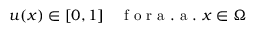<formula> <loc_0><loc_0><loc_500><loc_500>u ( x ) \in [ 0 , 1 ] \quad f o r a . a . x \in \Omega</formula> 